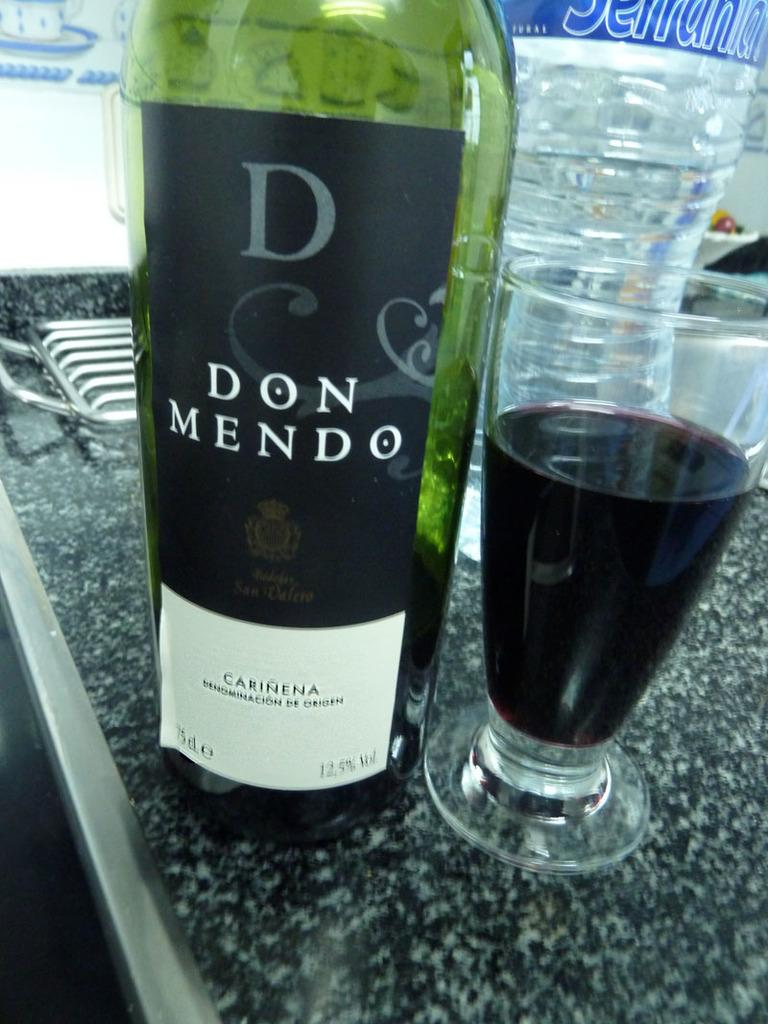<image>
Provide a brief description of the given image. A bottle of Don Mendo sits next to a glass on a table. 